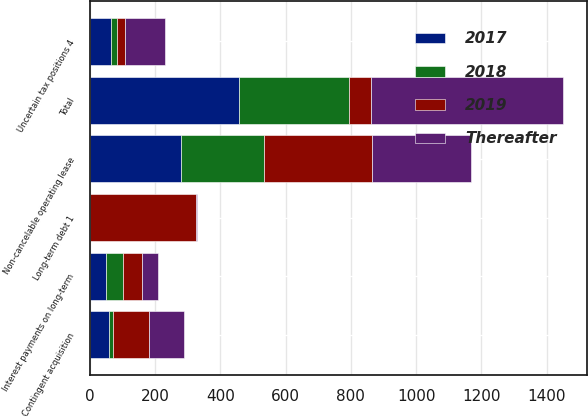Convert chart. <chart><loc_0><loc_0><loc_500><loc_500><stacked_bar_chart><ecel><fcel>Long-term debt 1<fcel>Interest payments on long-term<fcel>Non-cancelable operating lease<fcel>Contingent acquisition<fcel>Uncertain tax positions 4<fcel>Total<nl><fcel>2019<fcel>323.9<fcel>57.3<fcel>329.4<fcel>111.6<fcel>24<fcel>66.4<nl><fcel>Thereafter<fcel>1.8<fcel>51.3<fcel>305.5<fcel>108.1<fcel>123.2<fcel>589.9<nl><fcel>2017<fcel>1.7<fcel>51.3<fcel>279.8<fcel>58<fcel>66.4<fcel>457.2<nl><fcel>2018<fcel>0.8<fcel>51<fcel>254.8<fcel>12.8<fcel>18.2<fcel>337.6<nl></chart> 